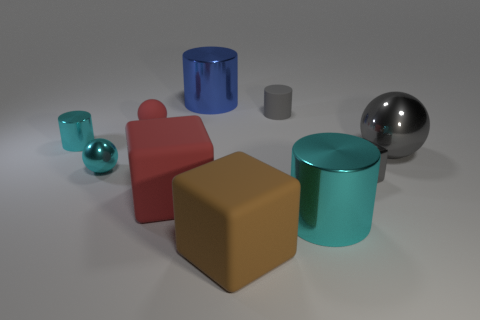What is the material of the small cube that is the same color as the large metal sphere?
Give a very brief answer. Metal. Does the large red block have the same material as the large gray object?
Your answer should be compact. No. What shape is the gray thing that is the same size as the rubber cylinder?
Provide a succinct answer. Cube. Are there more red matte blocks than red rubber things?
Make the answer very short. No. There is a thing that is both to the left of the large brown rubber object and in front of the tiny gray metallic object; what is its material?
Offer a terse response. Rubber. What number of other things are there of the same material as the large blue object
Your answer should be compact. 5. What number of metallic spheres have the same color as the small rubber cylinder?
Make the answer very short. 1. There is a rubber thing that is in front of the large cylinder in front of the shiny object that is behind the small matte ball; how big is it?
Provide a succinct answer. Large. How many rubber objects are either small gray cylinders or big objects?
Give a very brief answer. 3. There is a big blue metal thing; is it the same shape as the small gray object that is behind the small cyan sphere?
Provide a succinct answer. Yes. 